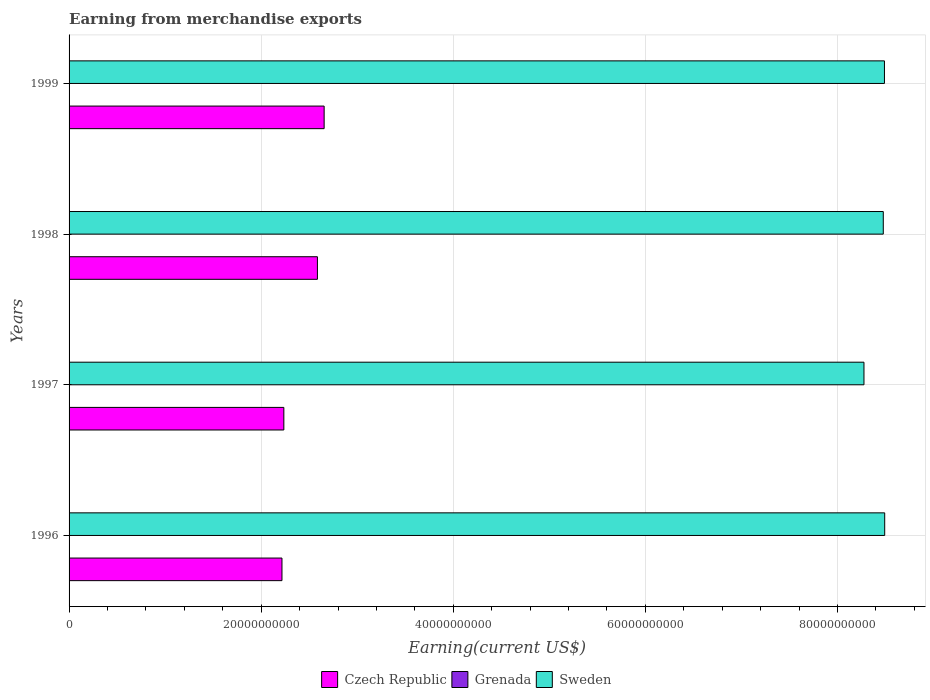Are the number of bars on each tick of the Y-axis equal?
Your response must be concise. Yes. How many bars are there on the 2nd tick from the top?
Offer a very short reply. 3. In how many cases, is the number of bars for a given year not equal to the number of legend labels?
Offer a terse response. 0. What is the amount earned from merchandise exports in Czech Republic in 1999?
Keep it short and to the point. 2.66e+1. Across all years, what is the maximum amount earned from merchandise exports in Grenada?
Provide a short and direct response. 3.60e+07. Across all years, what is the minimum amount earned from merchandise exports in Czech Republic?
Give a very brief answer. 2.22e+1. In which year was the amount earned from merchandise exports in Czech Republic maximum?
Your answer should be compact. 1999. What is the total amount earned from merchandise exports in Sweden in the graph?
Make the answer very short. 3.37e+11. What is the difference between the amount earned from merchandise exports in Grenada in 1997 and that in 1998?
Provide a short and direct response. -1.20e+07. What is the difference between the amount earned from merchandise exports in Grenada in 1996 and the amount earned from merchandise exports in Sweden in 1999?
Your answer should be very brief. -8.49e+1. What is the average amount earned from merchandise exports in Grenada per year?
Your answer should be compact. 2.85e+07. In the year 1999, what is the difference between the amount earned from merchandise exports in Sweden and amount earned from merchandise exports in Czech Republic?
Your answer should be very brief. 5.83e+1. What is the ratio of the amount earned from merchandise exports in Sweden in 1997 to that in 1998?
Make the answer very short. 0.98. What is the difference between the highest and the second highest amount earned from merchandise exports in Czech Republic?
Offer a terse response. 7.01e+08. What is the difference between the highest and the lowest amount earned from merchandise exports in Sweden?
Ensure brevity in your answer.  2.16e+09. What does the 2nd bar from the top in 1996 represents?
Keep it short and to the point. Grenada. What does the 3rd bar from the bottom in 1999 represents?
Keep it short and to the point. Sweden. Is it the case that in every year, the sum of the amount earned from merchandise exports in Sweden and amount earned from merchandise exports in Grenada is greater than the amount earned from merchandise exports in Czech Republic?
Offer a terse response. Yes. Are all the bars in the graph horizontal?
Provide a short and direct response. Yes. How many years are there in the graph?
Give a very brief answer. 4. Does the graph contain grids?
Give a very brief answer. Yes. What is the title of the graph?
Offer a very short reply. Earning from merchandise exports. What is the label or title of the X-axis?
Offer a terse response. Earning(current US$). What is the label or title of the Y-axis?
Provide a succinct answer. Years. What is the Earning(current US$) of Czech Republic in 1996?
Offer a terse response. 2.22e+1. What is the Earning(current US$) in Grenada in 1996?
Offer a terse response. 2.00e+07. What is the Earning(current US$) in Sweden in 1996?
Your response must be concise. 8.49e+1. What is the Earning(current US$) of Czech Republic in 1997?
Provide a short and direct response. 2.24e+1. What is the Earning(current US$) in Grenada in 1997?
Your response must be concise. 2.30e+07. What is the Earning(current US$) in Sweden in 1997?
Your answer should be very brief. 8.28e+1. What is the Earning(current US$) in Czech Republic in 1998?
Ensure brevity in your answer.  2.59e+1. What is the Earning(current US$) in Grenada in 1998?
Offer a very short reply. 3.50e+07. What is the Earning(current US$) of Sweden in 1998?
Provide a short and direct response. 8.48e+1. What is the Earning(current US$) of Czech Republic in 1999?
Your answer should be compact. 2.66e+1. What is the Earning(current US$) of Grenada in 1999?
Make the answer very short. 3.60e+07. What is the Earning(current US$) of Sweden in 1999?
Make the answer very short. 8.49e+1. Across all years, what is the maximum Earning(current US$) of Czech Republic?
Make the answer very short. 2.66e+1. Across all years, what is the maximum Earning(current US$) of Grenada?
Provide a succinct answer. 3.60e+07. Across all years, what is the maximum Earning(current US$) of Sweden?
Make the answer very short. 8.49e+1. Across all years, what is the minimum Earning(current US$) in Czech Republic?
Your answer should be very brief. 2.22e+1. Across all years, what is the minimum Earning(current US$) of Grenada?
Offer a terse response. 2.00e+07. Across all years, what is the minimum Earning(current US$) in Sweden?
Your answer should be very brief. 8.28e+1. What is the total Earning(current US$) of Czech Republic in the graph?
Offer a terse response. 9.69e+1. What is the total Earning(current US$) in Grenada in the graph?
Your response must be concise. 1.14e+08. What is the total Earning(current US$) in Sweden in the graph?
Offer a terse response. 3.37e+11. What is the difference between the Earning(current US$) of Czech Republic in 1996 and that in 1997?
Keep it short and to the point. -1.95e+08. What is the difference between the Earning(current US$) in Sweden in 1996 and that in 1997?
Keep it short and to the point. 2.16e+09. What is the difference between the Earning(current US$) of Czech Republic in 1996 and that in 1998?
Provide a succinct answer. -3.69e+09. What is the difference between the Earning(current US$) in Grenada in 1996 and that in 1998?
Your answer should be compact. -1.50e+07. What is the difference between the Earning(current US$) in Sweden in 1996 and that in 1998?
Offer a very short reply. 1.49e+08. What is the difference between the Earning(current US$) of Czech Republic in 1996 and that in 1999?
Offer a very short reply. -4.39e+09. What is the difference between the Earning(current US$) of Grenada in 1996 and that in 1999?
Make the answer very short. -1.60e+07. What is the difference between the Earning(current US$) in Sweden in 1996 and that in 1999?
Ensure brevity in your answer.  2.68e+07. What is the difference between the Earning(current US$) of Czech Republic in 1997 and that in 1998?
Offer a terse response. -3.50e+09. What is the difference between the Earning(current US$) of Grenada in 1997 and that in 1998?
Provide a short and direct response. -1.20e+07. What is the difference between the Earning(current US$) of Sweden in 1997 and that in 1998?
Offer a terse response. -2.01e+09. What is the difference between the Earning(current US$) in Czech Republic in 1997 and that in 1999?
Offer a terse response. -4.20e+09. What is the difference between the Earning(current US$) in Grenada in 1997 and that in 1999?
Provide a short and direct response. -1.30e+07. What is the difference between the Earning(current US$) of Sweden in 1997 and that in 1999?
Make the answer very short. -2.13e+09. What is the difference between the Earning(current US$) in Czech Republic in 1998 and that in 1999?
Offer a terse response. -7.01e+08. What is the difference between the Earning(current US$) of Grenada in 1998 and that in 1999?
Make the answer very short. -1.00e+06. What is the difference between the Earning(current US$) of Sweden in 1998 and that in 1999?
Your response must be concise. -1.22e+08. What is the difference between the Earning(current US$) of Czech Republic in 1996 and the Earning(current US$) of Grenada in 1997?
Ensure brevity in your answer.  2.21e+1. What is the difference between the Earning(current US$) of Czech Republic in 1996 and the Earning(current US$) of Sweden in 1997?
Make the answer very short. -6.06e+1. What is the difference between the Earning(current US$) in Grenada in 1996 and the Earning(current US$) in Sweden in 1997?
Make the answer very short. -8.27e+1. What is the difference between the Earning(current US$) in Czech Republic in 1996 and the Earning(current US$) in Grenada in 1998?
Keep it short and to the point. 2.21e+1. What is the difference between the Earning(current US$) of Czech Republic in 1996 and the Earning(current US$) of Sweden in 1998?
Give a very brief answer. -6.26e+1. What is the difference between the Earning(current US$) of Grenada in 1996 and the Earning(current US$) of Sweden in 1998?
Give a very brief answer. -8.47e+1. What is the difference between the Earning(current US$) in Czech Republic in 1996 and the Earning(current US$) in Grenada in 1999?
Your answer should be very brief. 2.21e+1. What is the difference between the Earning(current US$) in Czech Republic in 1996 and the Earning(current US$) in Sweden in 1999?
Your response must be concise. -6.27e+1. What is the difference between the Earning(current US$) in Grenada in 1996 and the Earning(current US$) in Sweden in 1999?
Offer a very short reply. -8.49e+1. What is the difference between the Earning(current US$) of Czech Republic in 1997 and the Earning(current US$) of Grenada in 1998?
Give a very brief answer. 2.23e+1. What is the difference between the Earning(current US$) in Czech Republic in 1997 and the Earning(current US$) in Sweden in 1998?
Make the answer very short. -6.24e+1. What is the difference between the Earning(current US$) in Grenada in 1997 and the Earning(current US$) in Sweden in 1998?
Your response must be concise. -8.47e+1. What is the difference between the Earning(current US$) in Czech Republic in 1997 and the Earning(current US$) in Grenada in 1999?
Your answer should be very brief. 2.23e+1. What is the difference between the Earning(current US$) in Czech Republic in 1997 and the Earning(current US$) in Sweden in 1999?
Keep it short and to the point. -6.25e+1. What is the difference between the Earning(current US$) of Grenada in 1997 and the Earning(current US$) of Sweden in 1999?
Provide a succinct answer. -8.49e+1. What is the difference between the Earning(current US$) in Czech Republic in 1998 and the Earning(current US$) in Grenada in 1999?
Give a very brief answer. 2.58e+1. What is the difference between the Earning(current US$) of Czech Republic in 1998 and the Earning(current US$) of Sweden in 1999?
Your answer should be very brief. -5.90e+1. What is the difference between the Earning(current US$) in Grenada in 1998 and the Earning(current US$) in Sweden in 1999?
Your answer should be compact. -8.49e+1. What is the average Earning(current US$) in Czech Republic per year?
Provide a short and direct response. 2.42e+1. What is the average Earning(current US$) of Grenada per year?
Offer a very short reply. 2.85e+07. What is the average Earning(current US$) of Sweden per year?
Provide a succinct answer. 8.43e+1. In the year 1996, what is the difference between the Earning(current US$) of Czech Republic and Earning(current US$) of Grenada?
Offer a very short reply. 2.21e+1. In the year 1996, what is the difference between the Earning(current US$) of Czech Republic and Earning(current US$) of Sweden?
Your answer should be compact. -6.28e+1. In the year 1996, what is the difference between the Earning(current US$) in Grenada and Earning(current US$) in Sweden?
Ensure brevity in your answer.  -8.49e+1. In the year 1997, what is the difference between the Earning(current US$) in Czech Republic and Earning(current US$) in Grenada?
Your answer should be very brief. 2.23e+1. In the year 1997, what is the difference between the Earning(current US$) in Czech Republic and Earning(current US$) in Sweden?
Provide a short and direct response. -6.04e+1. In the year 1997, what is the difference between the Earning(current US$) in Grenada and Earning(current US$) in Sweden?
Offer a very short reply. -8.27e+1. In the year 1998, what is the difference between the Earning(current US$) of Czech Republic and Earning(current US$) of Grenada?
Provide a short and direct response. 2.58e+1. In the year 1998, what is the difference between the Earning(current US$) of Czech Republic and Earning(current US$) of Sweden?
Your answer should be very brief. -5.89e+1. In the year 1998, what is the difference between the Earning(current US$) in Grenada and Earning(current US$) in Sweden?
Provide a short and direct response. -8.47e+1. In the year 1999, what is the difference between the Earning(current US$) of Czech Republic and Earning(current US$) of Grenada?
Your answer should be compact. 2.65e+1. In the year 1999, what is the difference between the Earning(current US$) of Czech Republic and Earning(current US$) of Sweden?
Provide a short and direct response. -5.83e+1. In the year 1999, what is the difference between the Earning(current US$) of Grenada and Earning(current US$) of Sweden?
Make the answer very short. -8.49e+1. What is the ratio of the Earning(current US$) of Czech Republic in 1996 to that in 1997?
Provide a short and direct response. 0.99. What is the ratio of the Earning(current US$) of Grenada in 1996 to that in 1997?
Give a very brief answer. 0.87. What is the ratio of the Earning(current US$) in Sweden in 1996 to that in 1997?
Give a very brief answer. 1.03. What is the ratio of the Earning(current US$) in Czech Republic in 1996 to that in 1998?
Offer a terse response. 0.86. What is the ratio of the Earning(current US$) of Czech Republic in 1996 to that in 1999?
Ensure brevity in your answer.  0.83. What is the ratio of the Earning(current US$) of Grenada in 1996 to that in 1999?
Your response must be concise. 0.56. What is the ratio of the Earning(current US$) in Czech Republic in 1997 to that in 1998?
Offer a terse response. 0.86. What is the ratio of the Earning(current US$) of Grenada in 1997 to that in 1998?
Offer a terse response. 0.66. What is the ratio of the Earning(current US$) in Sweden in 1997 to that in 1998?
Make the answer very short. 0.98. What is the ratio of the Earning(current US$) in Czech Republic in 1997 to that in 1999?
Your answer should be very brief. 0.84. What is the ratio of the Earning(current US$) in Grenada in 1997 to that in 1999?
Give a very brief answer. 0.64. What is the ratio of the Earning(current US$) in Sweden in 1997 to that in 1999?
Your answer should be compact. 0.97. What is the ratio of the Earning(current US$) of Czech Republic in 1998 to that in 1999?
Your answer should be very brief. 0.97. What is the ratio of the Earning(current US$) in Grenada in 1998 to that in 1999?
Make the answer very short. 0.97. What is the ratio of the Earning(current US$) in Sweden in 1998 to that in 1999?
Ensure brevity in your answer.  1. What is the difference between the highest and the second highest Earning(current US$) in Czech Republic?
Offer a very short reply. 7.01e+08. What is the difference between the highest and the second highest Earning(current US$) of Grenada?
Keep it short and to the point. 1.00e+06. What is the difference between the highest and the second highest Earning(current US$) of Sweden?
Make the answer very short. 2.68e+07. What is the difference between the highest and the lowest Earning(current US$) in Czech Republic?
Provide a short and direct response. 4.39e+09. What is the difference between the highest and the lowest Earning(current US$) of Grenada?
Your answer should be very brief. 1.60e+07. What is the difference between the highest and the lowest Earning(current US$) in Sweden?
Make the answer very short. 2.16e+09. 